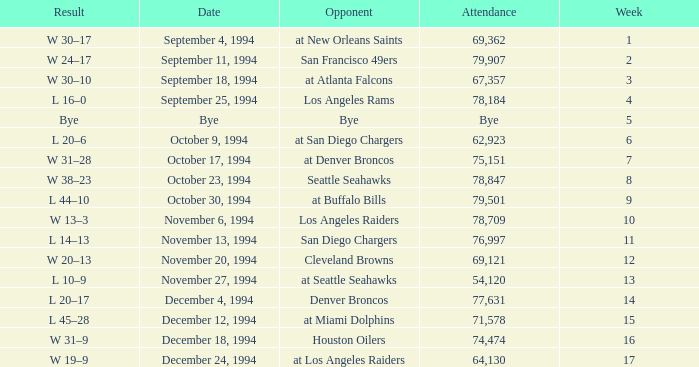What was the score of the Chiefs November 27, 1994 game? L 10–9. 